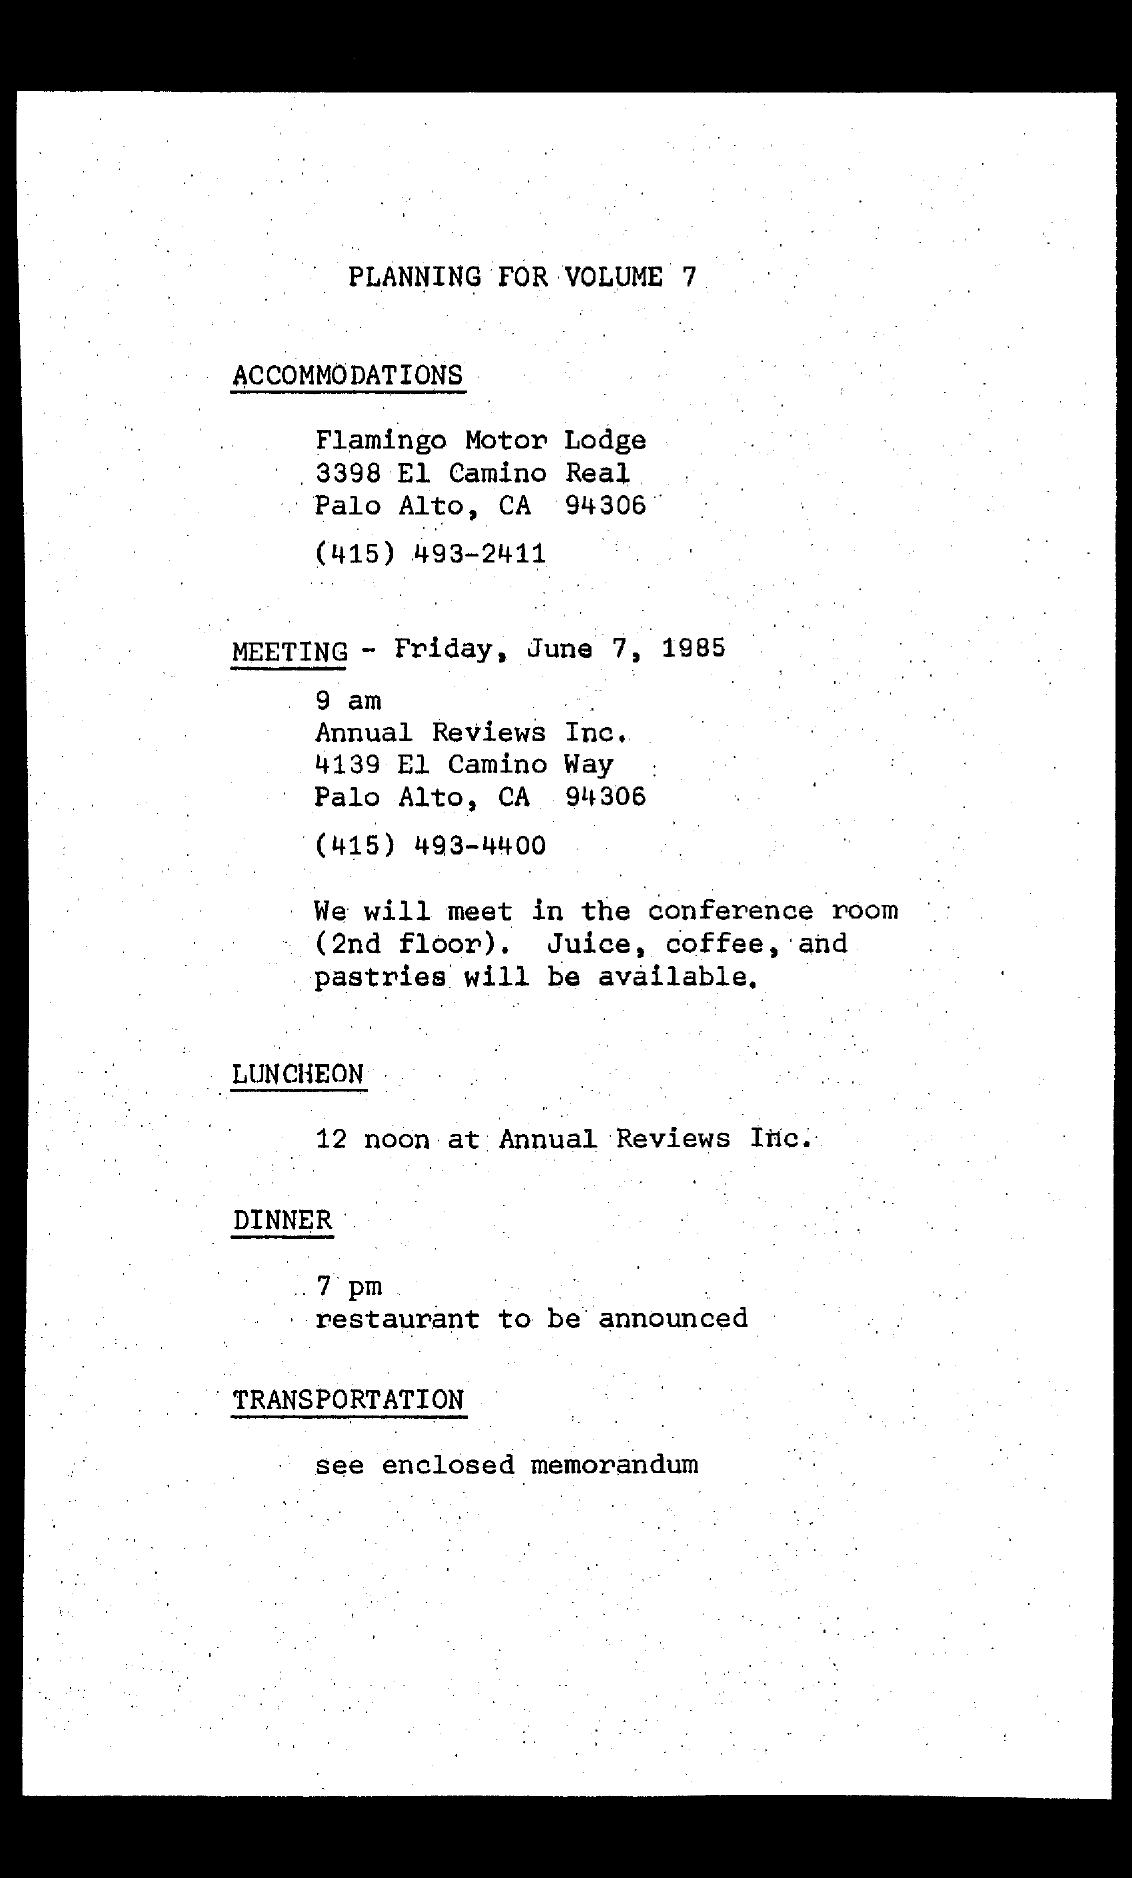When is the meeting scheduled as per the document?
Your answer should be very brief. Friday, June 7, 1985. Where is the Accomodation arranged as per the plan?
Ensure brevity in your answer.  Flamingo Motor Lodge. What is the contact no of Annual Reviews Inc. given?
Your response must be concise. (415) 493-4400. What time is the dinner scheduled as per the plan?
Give a very brief answer. 7 pm. What time does the meeting start on Friday, June 7, 1985?
Give a very brief answer. 9 am. 